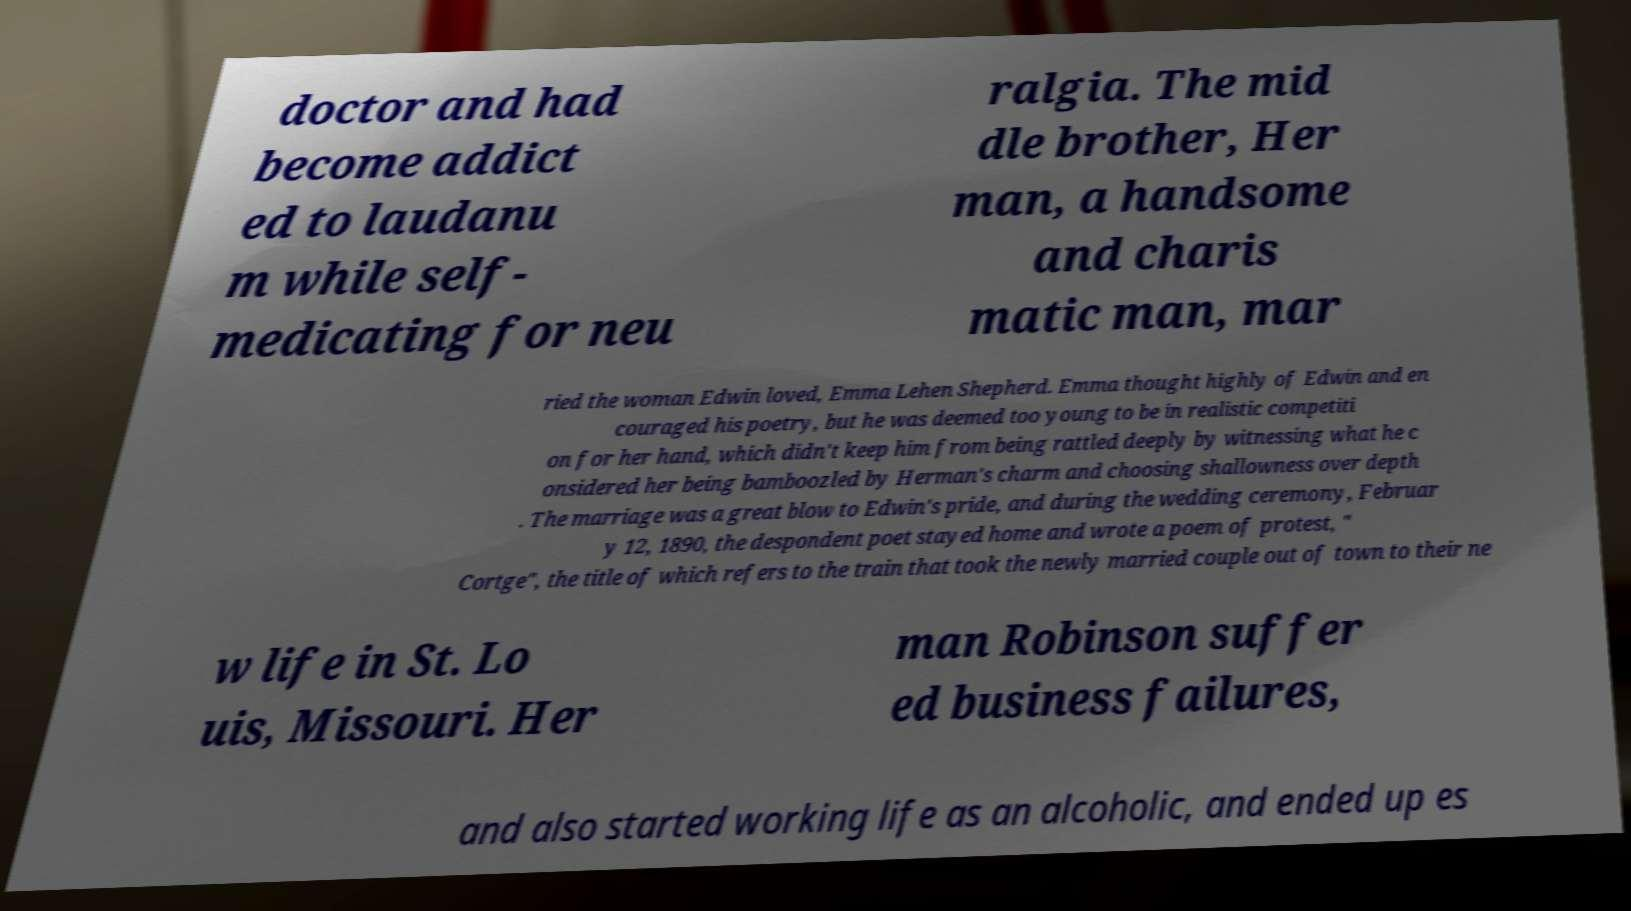I need the written content from this picture converted into text. Can you do that? doctor and had become addict ed to laudanu m while self- medicating for neu ralgia. The mid dle brother, Her man, a handsome and charis matic man, mar ried the woman Edwin loved, Emma Lehen Shepherd. Emma thought highly of Edwin and en couraged his poetry, but he was deemed too young to be in realistic competiti on for her hand, which didn't keep him from being rattled deeply by witnessing what he c onsidered her being bamboozled by Herman's charm and choosing shallowness over depth . The marriage was a great blow to Edwin's pride, and during the wedding ceremony, Februar y 12, 1890, the despondent poet stayed home and wrote a poem of protest, " Cortge", the title of which refers to the train that took the newly married couple out of town to their ne w life in St. Lo uis, Missouri. Her man Robinson suffer ed business failures, and also started working life as an alcoholic, and ended up es 